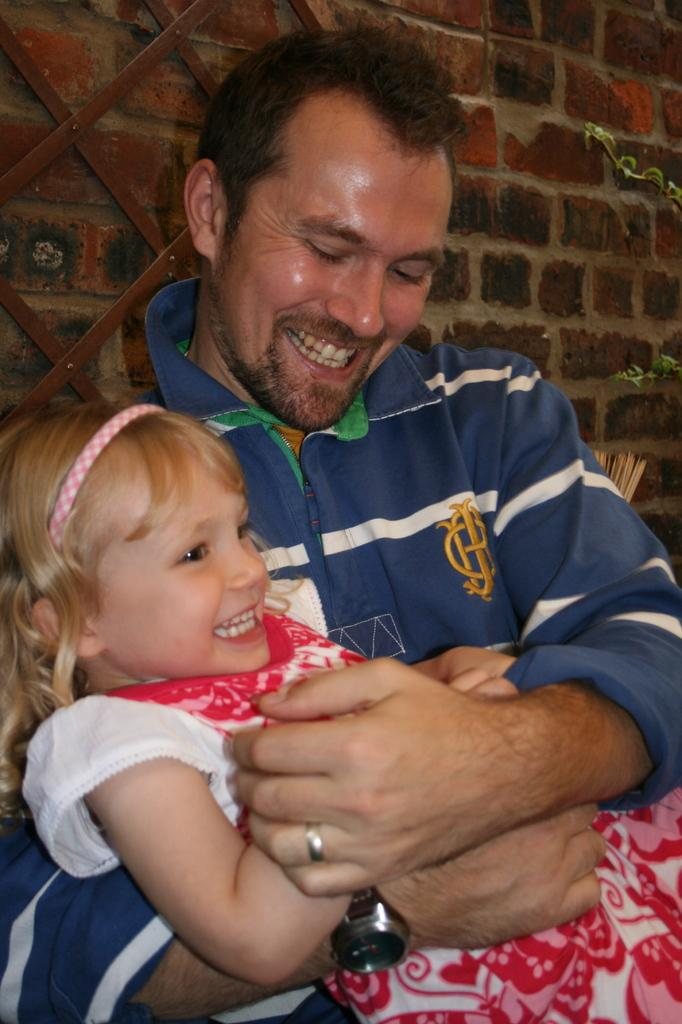Who is the main subject in the image? There is a girl in the image. What is the girl doing in the image? The girl is laying on a person. Can you describe the person in the image? There is a person in the image. How is the girl positioned in relation to the person? The girl is laying on the person. What can be seen in the background of the image? There is a wall in the background of the image. How many pears are visible in the image? There are no pears present in the image. Is the story depicted in the image based on fiction or non-fiction? The image is not a story, so it cannot be classified as fiction or non-fiction. 